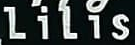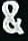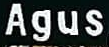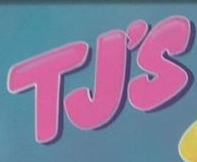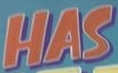Read the text content from these images in order, separated by a semicolon. LiLis; &; Agus; TJ'S; HAS 